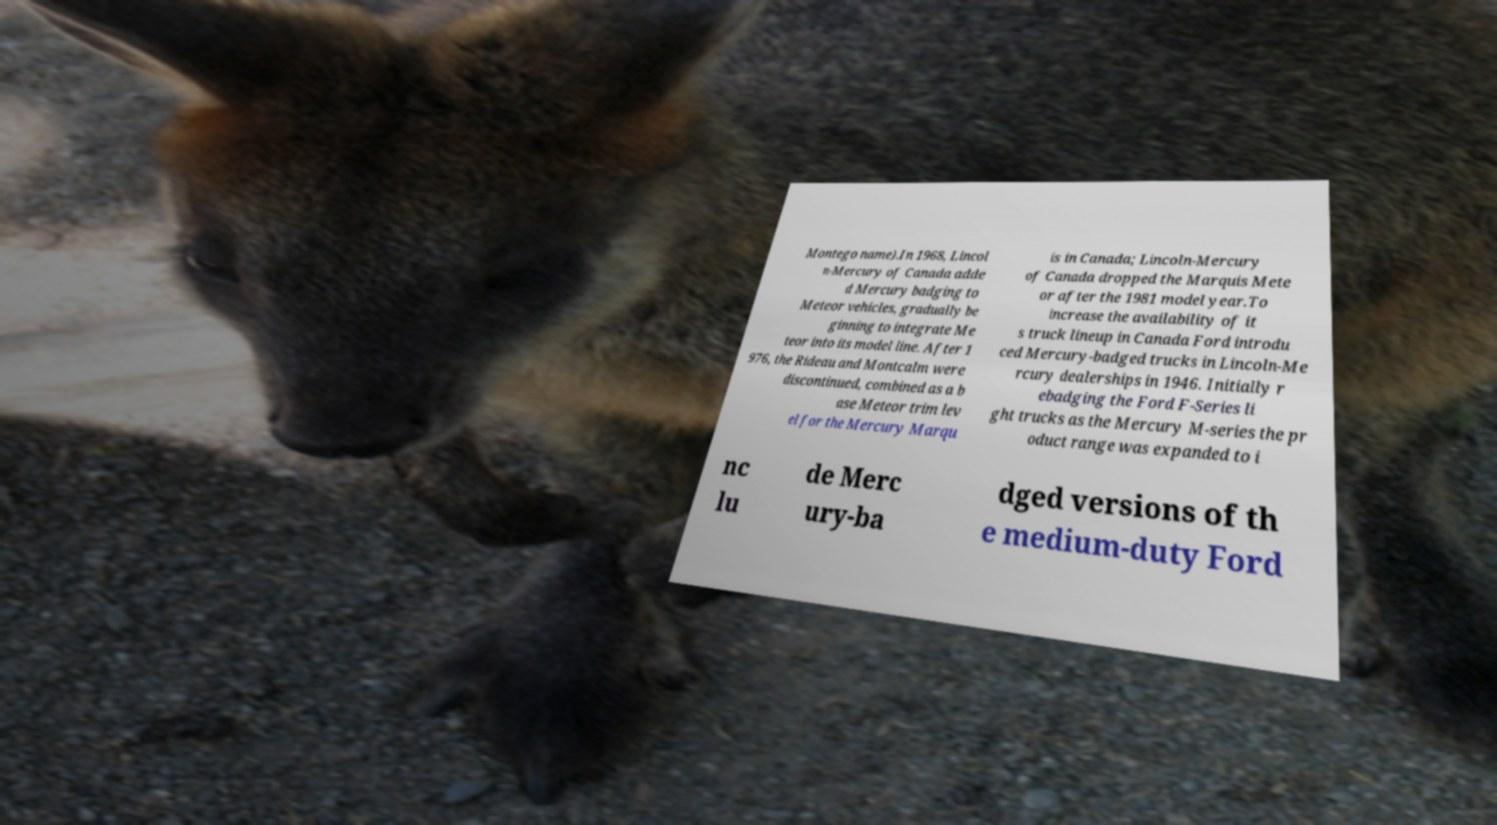I need the written content from this picture converted into text. Can you do that? Montego name).In 1968, Lincol n-Mercury of Canada adde d Mercury badging to Meteor vehicles, gradually be ginning to integrate Me teor into its model line. After 1 976, the Rideau and Montcalm were discontinued, combined as a b ase Meteor trim lev el for the Mercury Marqu is in Canada; Lincoln-Mercury of Canada dropped the Marquis Mete or after the 1981 model year.To increase the availability of it s truck lineup in Canada Ford introdu ced Mercury-badged trucks in Lincoln-Me rcury dealerships in 1946. Initially r ebadging the Ford F-Series li ght trucks as the Mercury M-series the pr oduct range was expanded to i nc lu de Merc ury-ba dged versions of th e medium-duty Ford 